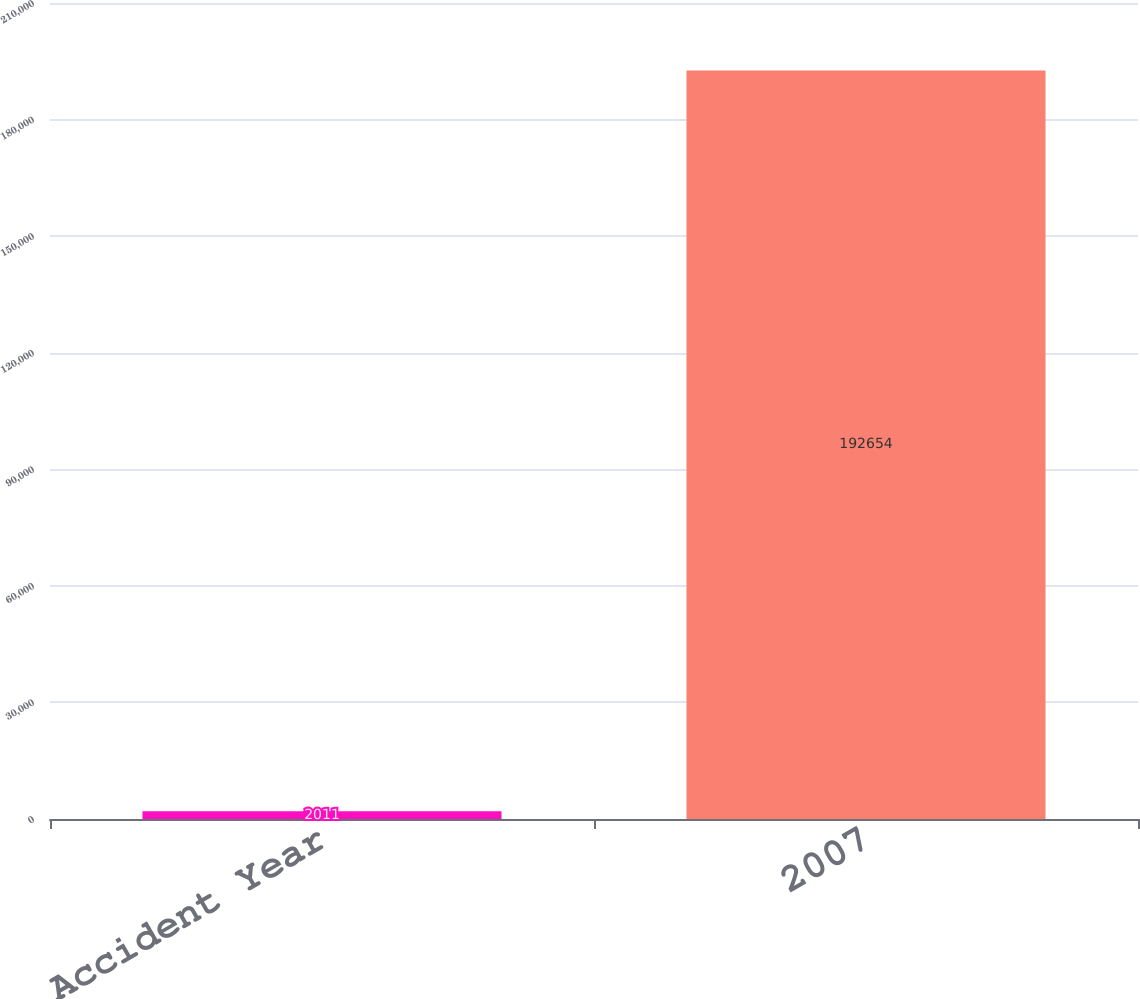Convert chart to OTSL. <chart><loc_0><loc_0><loc_500><loc_500><bar_chart><fcel>Accident Year<fcel>2007<nl><fcel>2011<fcel>192654<nl></chart> 